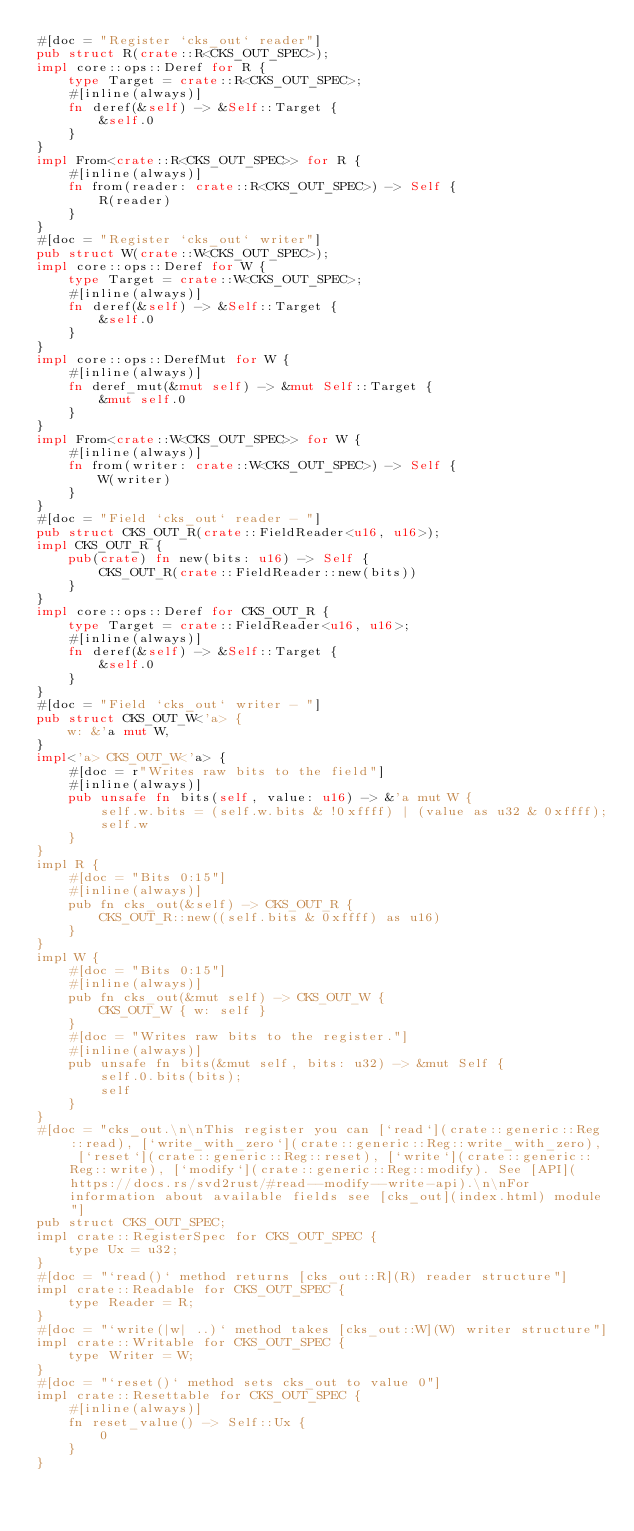<code> <loc_0><loc_0><loc_500><loc_500><_Rust_>#[doc = "Register `cks_out` reader"]
pub struct R(crate::R<CKS_OUT_SPEC>);
impl core::ops::Deref for R {
    type Target = crate::R<CKS_OUT_SPEC>;
    #[inline(always)]
    fn deref(&self) -> &Self::Target {
        &self.0
    }
}
impl From<crate::R<CKS_OUT_SPEC>> for R {
    #[inline(always)]
    fn from(reader: crate::R<CKS_OUT_SPEC>) -> Self {
        R(reader)
    }
}
#[doc = "Register `cks_out` writer"]
pub struct W(crate::W<CKS_OUT_SPEC>);
impl core::ops::Deref for W {
    type Target = crate::W<CKS_OUT_SPEC>;
    #[inline(always)]
    fn deref(&self) -> &Self::Target {
        &self.0
    }
}
impl core::ops::DerefMut for W {
    #[inline(always)]
    fn deref_mut(&mut self) -> &mut Self::Target {
        &mut self.0
    }
}
impl From<crate::W<CKS_OUT_SPEC>> for W {
    #[inline(always)]
    fn from(writer: crate::W<CKS_OUT_SPEC>) -> Self {
        W(writer)
    }
}
#[doc = "Field `cks_out` reader - "]
pub struct CKS_OUT_R(crate::FieldReader<u16, u16>);
impl CKS_OUT_R {
    pub(crate) fn new(bits: u16) -> Self {
        CKS_OUT_R(crate::FieldReader::new(bits))
    }
}
impl core::ops::Deref for CKS_OUT_R {
    type Target = crate::FieldReader<u16, u16>;
    #[inline(always)]
    fn deref(&self) -> &Self::Target {
        &self.0
    }
}
#[doc = "Field `cks_out` writer - "]
pub struct CKS_OUT_W<'a> {
    w: &'a mut W,
}
impl<'a> CKS_OUT_W<'a> {
    #[doc = r"Writes raw bits to the field"]
    #[inline(always)]
    pub unsafe fn bits(self, value: u16) -> &'a mut W {
        self.w.bits = (self.w.bits & !0xffff) | (value as u32 & 0xffff);
        self.w
    }
}
impl R {
    #[doc = "Bits 0:15"]
    #[inline(always)]
    pub fn cks_out(&self) -> CKS_OUT_R {
        CKS_OUT_R::new((self.bits & 0xffff) as u16)
    }
}
impl W {
    #[doc = "Bits 0:15"]
    #[inline(always)]
    pub fn cks_out(&mut self) -> CKS_OUT_W {
        CKS_OUT_W { w: self }
    }
    #[doc = "Writes raw bits to the register."]
    #[inline(always)]
    pub unsafe fn bits(&mut self, bits: u32) -> &mut Self {
        self.0.bits(bits);
        self
    }
}
#[doc = "cks_out.\n\nThis register you can [`read`](crate::generic::Reg::read), [`write_with_zero`](crate::generic::Reg::write_with_zero), [`reset`](crate::generic::Reg::reset), [`write`](crate::generic::Reg::write), [`modify`](crate::generic::Reg::modify). See [API](https://docs.rs/svd2rust/#read--modify--write-api).\n\nFor information about available fields see [cks_out](index.html) module"]
pub struct CKS_OUT_SPEC;
impl crate::RegisterSpec for CKS_OUT_SPEC {
    type Ux = u32;
}
#[doc = "`read()` method returns [cks_out::R](R) reader structure"]
impl crate::Readable for CKS_OUT_SPEC {
    type Reader = R;
}
#[doc = "`write(|w| ..)` method takes [cks_out::W](W) writer structure"]
impl crate::Writable for CKS_OUT_SPEC {
    type Writer = W;
}
#[doc = "`reset()` method sets cks_out to value 0"]
impl crate::Resettable for CKS_OUT_SPEC {
    #[inline(always)]
    fn reset_value() -> Self::Ux {
        0
    }
}
</code> 